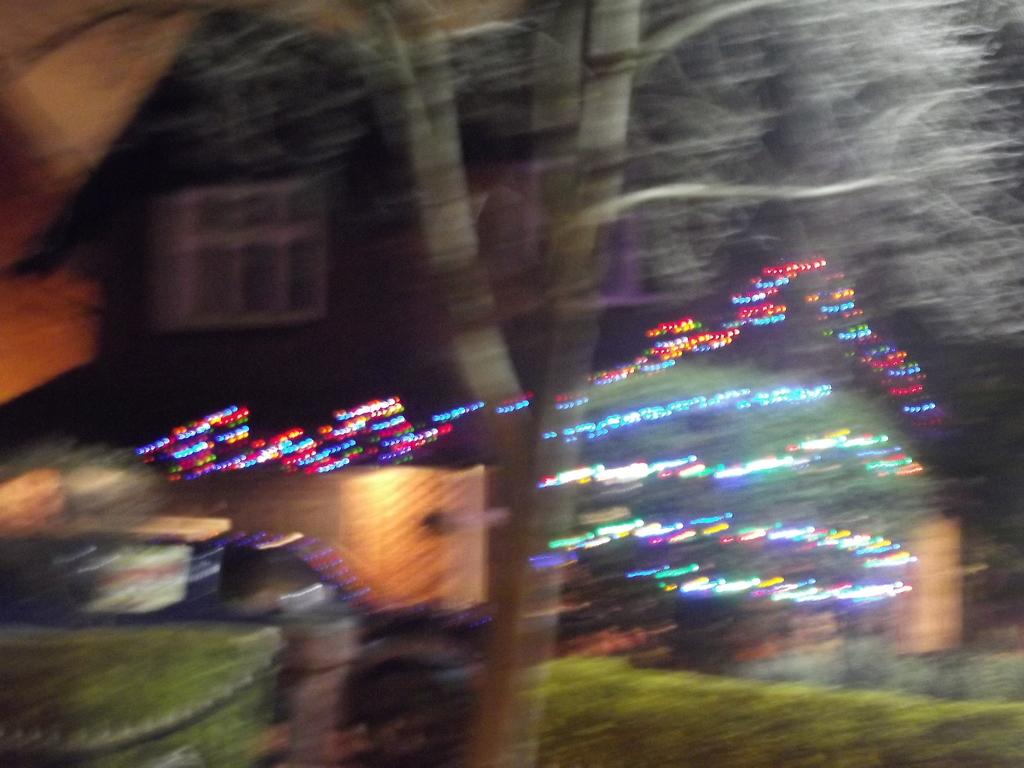What is the overall quality of the image? The image is blurry. What type of tree can be seen in the image? There is a dry tree in the image. Where are the plants located in the image? The plants are present in the bottom right and left of the image. What can be seen in the background of the image? There is a house in the background of the image. What type of sugar is being used to sweeten the apple in the image? There is no apple or sugar present in the image; it features a dry tree, plants, and a house in the background. 